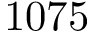<formula> <loc_0><loc_0><loc_500><loc_500>1 0 7 5</formula> 